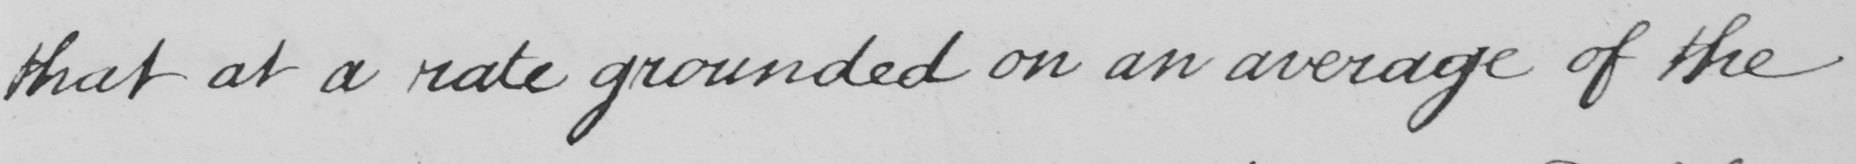Can you read and transcribe this handwriting? that at a rate grounded on an average of the 